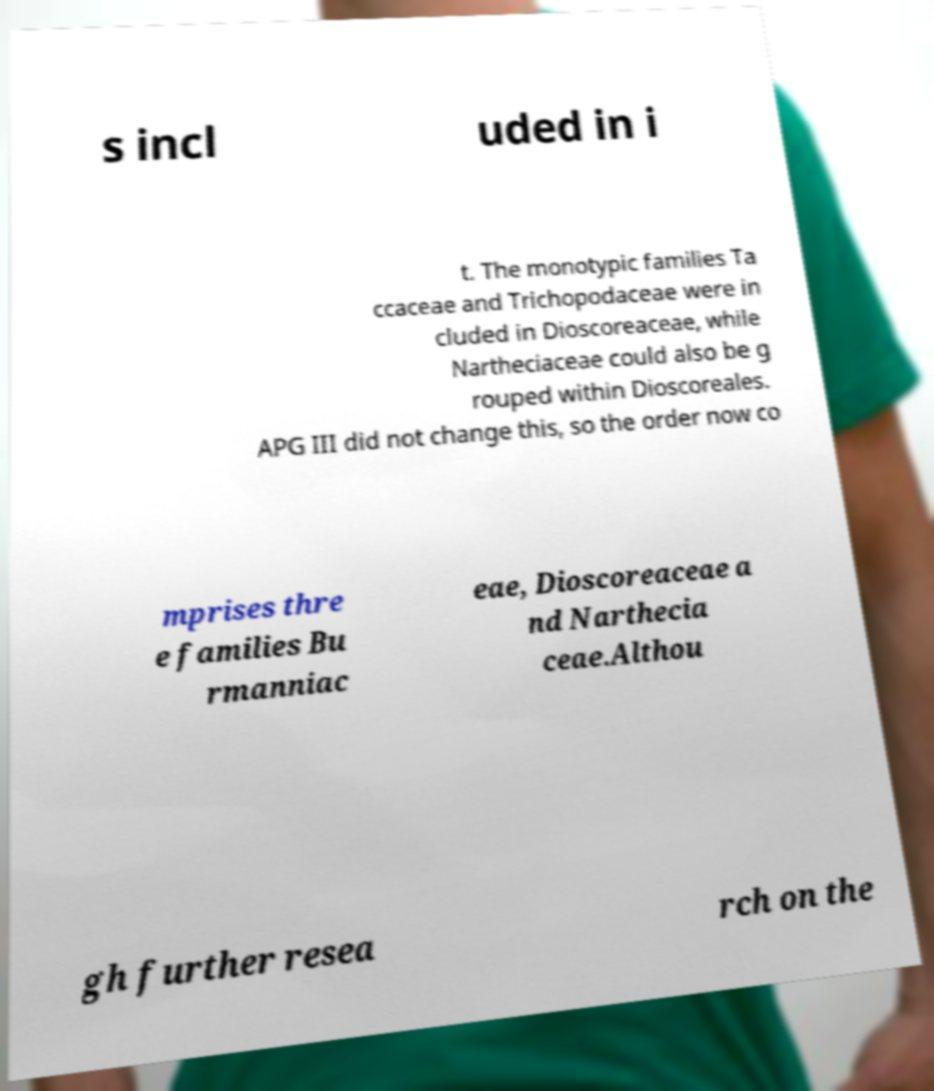Please read and relay the text visible in this image. What does it say? s incl uded in i t. The monotypic families Ta ccaceae and Trichopodaceae were in cluded in Dioscoreaceae, while Nartheciaceae could also be g rouped within Dioscoreales. APG III did not change this, so the order now co mprises thre e families Bu rmanniac eae, Dioscoreaceae a nd Narthecia ceae.Althou gh further resea rch on the 